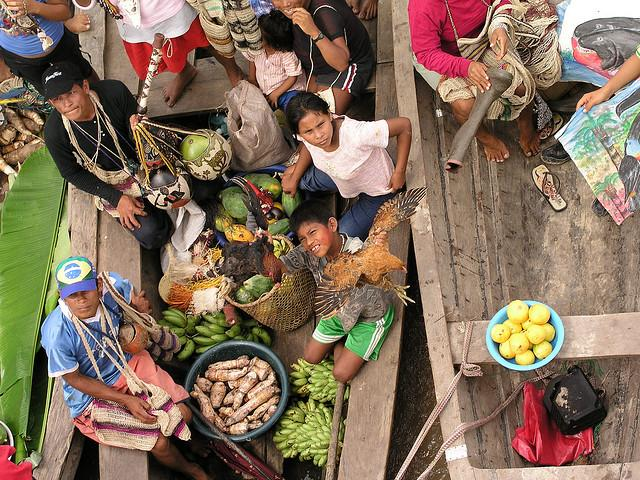Where are the persons here headed? Please explain your reasoning. market. The people are headed to the produce market. 